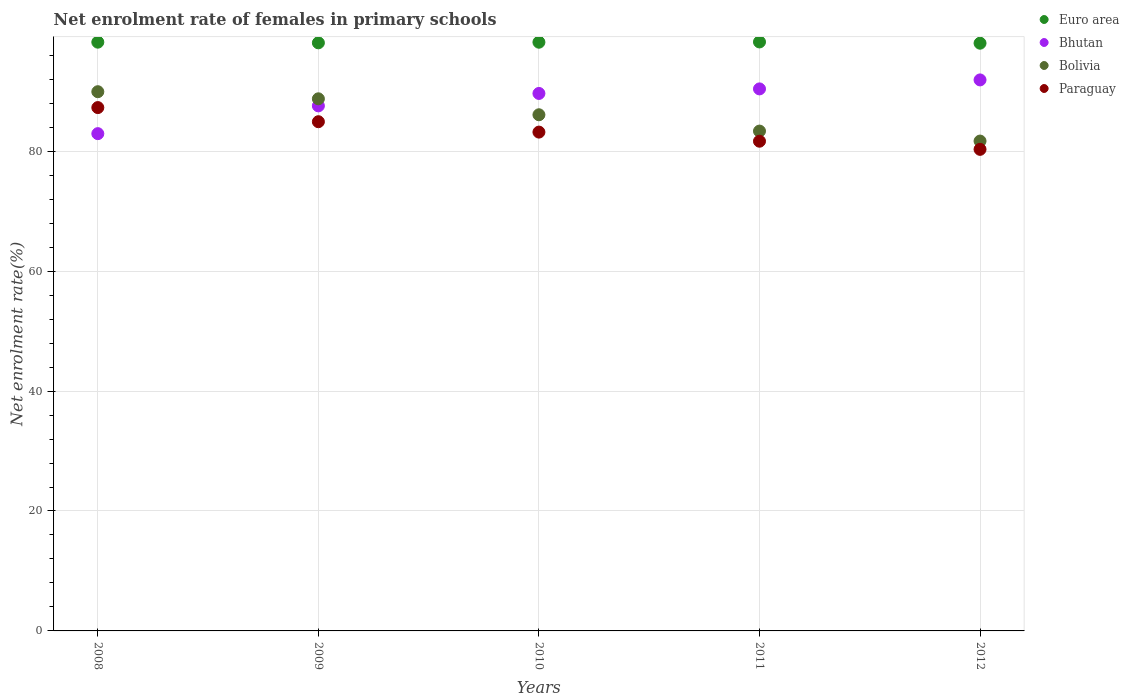What is the net enrolment rate of females in primary schools in Bolivia in 2010?
Provide a short and direct response. 86.08. Across all years, what is the maximum net enrolment rate of females in primary schools in Paraguay?
Ensure brevity in your answer.  87.28. Across all years, what is the minimum net enrolment rate of females in primary schools in Euro area?
Provide a succinct answer. 98.01. In which year was the net enrolment rate of females in primary schools in Paraguay maximum?
Your response must be concise. 2008. In which year was the net enrolment rate of females in primary schools in Bhutan minimum?
Your answer should be compact. 2008. What is the total net enrolment rate of females in primary schools in Euro area in the graph?
Your answer should be very brief. 490.67. What is the difference between the net enrolment rate of females in primary schools in Bolivia in 2010 and that in 2011?
Offer a very short reply. 2.72. What is the difference between the net enrolment rate of females in primary schools in Bolivia in 2010 and the net enrolment rate of females in primary schools in Euro area in 2008?
Your response must be concise. -12.11. What is the average net enrolment rate of females in primary schools in Euro area per year?
Your answer should be very brief. 98.13. In the year 2012, what is the difference between the net enrolment rate of females in primary schools in Euro area and net enrolment rate of females in primary schools in Bhutan?
Provide a succinct answer. 6.12. What is the ratio of the net enrolment rate of females in primary schools in Bhutan in 2009 to that in 2011?
Offer a very short reply. 0.97. Is the net enrolment rate of females in primary schools in Bolivia in 2008 less than that in 2012?
Your response must be concise. No. Is the difference between the net enrolment rate of females in primary schools in Euro area in 2009 and 2011 greater than the difference between the net enrolment rate of females in primary schools in Bhutan in 2009 and 2011?
Provide a short and direct response. Yes. What is the difference between the highest and the second highest net enrolment rate of females in primary schools in Paraguay?
Make the answer very short. 2.36. What is the difference between the highest and the lowest net enrolment rate of females in primary schools in Bhutan?
Provide a short and direct response. 8.96. Does the net enrolment rate of females in primary schools in Bolivia monotonically increase over the years?
Give a very brief answer. No. How many dotlines are there?
Your answer should be compact. 4. Does the graph contain grids?
Make the answer very short. Yes. How many legend labels are there?
Keep it short and to the point. 4. How are the legend labels stacked?
Your answer should be very brief. Vertical. What is the title of the graph?
Your answer should be compact. Net enrolment rate of females in primary schools. What is the label or title of the X-axis?
Provide a short and direct response. Years. What is the label or title of the Y-axis?
Keep it short and to the point. Net enrolment rate(%). What is the Net enrolment rate(%) of Euro area in 2008?
Your answer should be compact. 98.19. What is the Net enrolment rate(%) in Bhutan in 2008?
Give a very brief answer. 82.93. What is the Net enrolment rate(%) of Bolivia in 2008?
Provide a succinct answer. 89.92. What is the Net enrolment rate(%) in Paraguay in 2008?
Your answer should be compact. 87.28. What is the Net enrolment rate(%) in Euro area in 2009?
Your answer should be compact. 98.08. What is the Net enrolment rate(%) of Bhutan in 2009?
Provide a short and direct response. 87.56. What is the Net enrolment rate(%) of Bolivia in 2009?
Provide a short and direct response. 88.74. What is the Net enrolment rate(%) of Paraguay in 2009?
Your answer should be very brief. 84.92. What is the Net enrolment rate(%) of Euro area in 2010?
Provide a short and direct response. 98.18. What is the Net enrolment rate(%) of Bhutan in 2010?
Ensure brevity in your answer.  89.63. What is the Net enrolment rate(%) in Bolivia in 2010?
Make the answer very short. 86.08. What is the Net enrolment rate(%) in Paraguay in 2010?
Your answer should be compact. 83.19. What is the Net enrolment rate(%) in Euro area in 2011?
Ensure brevity in your answer.  98.22. What is the Net enrolment rate(%) in Bhutan in 2011?
Give a very brief answer. 90.39. What is the Net enrolment rate(%) of Bolivia in 2011?
Make the answer very short. 83.36. What is the Net enrolment rate(%) of Paraguay in 2011?
Provide a succinct answer. 81.67. What is the Net enrolment rate(%) in Euro area in 2012?
Offer a terse response. 98.01. What is the Net enrolment rate(%) in Bhutan in 2012?
Your answer should be compact. 91.89. What is the Net enrolment rate(%) in Bolivia in 2012?
Your answer should be compact. 81.69. What is the Net enrolment rate(%) in Paraguay in 2012?
Offer a very short reply. 80.31. Across all years, what is the maximum Net enrolment rate(%) of Euro area?
Make the answer very short. 98.22. Across all years, what is the maximum Net enrolment rate(%) of Bhutan?
Give a very brief answer. 91.89. Across all years, what is the maximum Net enrolment rate(%) of Bolivia?
Keep it short and to the point. 89.92. Across all years, what is the maximum Net enrolment rate(%) of Paraguay?
Provide a succinct answer. 87.28. Across all years, what is the minimum Net enrolment rate(%) of Euro area?
Your response must be concise. 98.01. Across all years, what is the minimum Net enrolment rate(%) of Bhutan?
Your answer should be compact. 82.93. Across all years, what is the minimum Net enrolment rate(%) of Bolivia?
Keep it short and to the point. 81.69. Across all years, what is the minimum Net enrolment rate(%) in Paraguay?
Your answer should be compact. 80.31. What is the total Net enrolment rate(%) in Euro area in the graph?
Provide a succinct answer. 490.67. What is the total Net enrolment rate(%) of Bhutan in the graph?
Provide a short and direct response. 442.41. What is the total Net enrolment rate(%) in Bolivia in the graph?
Offer a terse response. 429.79. What is the total Net enrolment rate(%) in Paraguay in the graph?
Provide a succinct answer. 417.36. What is the difference between the Net enrolment rate(%) in Euro area in 2008 and that in 2009?
Your answer should be compact. 0.11. What is the difference between the Net enrolment rate(%) of Bhutan in 2008 and that in 2009?
Make the answer very short. -4.63. What is the difference between the Net enrolment rate(%) of Bolivia in 2008 and that in 2009?
Give a very brief answer. 1.18. What is the difference between the Net enrolment rate(%) of Paraguay in 2008 and that in 2009?
Your answer should be very brief. 2.36. What is the difference between the Net enrolment rate(%) in Euro area in 2008 and that in 2010?
Provide a short and direct response. 0.01. What is the difference between the Net enrolment rate(%) in Bhutan in 2008 and that in 2010?
Your answer should be very brief. -6.71. What is the difference between the Net enrolment rate(%) of Bolivia in 2008 and that in 2010?
Make the answer very short. 3.85. What is the difference between the Net enrolment rate(%) of Paraguay in 2008 and that in 2010?
Offer a very short reply. 4.09. What is the difference between the Net enrolment rate(%) in Euro area in 2008 and that in 2011?
Provide a short and direct response. -0.04. What is the difference between the Net enrolment rate(%) in Bhutan in 2008 and that in 2011?
Your response must be concise. -7.46. What is the difference between the Net enrolment rate(%) of Bolivia in 2008 and that in 2011?
Provide a succinct answer. 6.57. What is the difference between the Net enrolment rate(%) of Paraguay in 2008 and that in 2011?
Keep it short and to the point. 5.61. What is the difference between the Net enrolment rate(%) of Euro area in 2008 and that in 2012?
Provide a succinct answer. 0.17. What is the difference between the Net enrolment rate(%) of Bhutan in 2008 and that in 2012?
Your answer should be compact. -8.96. What is the difference between the Net enrolment rate(%) in Bolivia in 2008 and that in 2012?
Keep it short and to the point. 8.23. What is the difference between the Net enrolment rate(%) in Paraguay in 2008 and that in 2012?
Offer a terse response. 6.97. What is the difference between the Net enrolment rate(%) of Euro area in 2009 and that in 2010?
Provide a short and direct response. -0.1. What is the difference between the Net enrolment rate(%) in Bhutan in 2009 and that in 2010?
Your answer should be very brief. -2.07. What is the difference between the Net enrolment rate(%) in Bolivia in 2009 and that in 2010?
Give a very brief answer. 2.66. What is the difference between the Net enrolment rate(%) in Paraguay in 2009 and that in 2010?
Offer a terse response. 1.73. What is the difference between the Net enrolment rate(%) in Euro area in 2009 and that in 2011?
Your answer should be very brief. -0.15. What is the difference between the Net enrolment rate(%) in Bhutan in 2009 and that in 2011?
Offer a terse response. -2.83. What is the difference between the Net enrolment rate(%) in Bolivia in 2009 and that in 2011?
Provide a succinct answer. 5.38. What is the difference between the Net enrolment rate(%) of Paraguay in 2009 and that in 2011?
Give a very brief answer. 3.25. What is the difference between the Net enrolment rate(%) of Euro area in 2009 and that in 2012?
Provide a short and direct response. 0.06. What is the difference between the Net enrolment rate(%) in Bhutan in 2009 and that in 2012?
Your response must be concise. -4.33. What is the difference between the Net enrolment rate(%) in Bolivia in 2009 and that in 2012?
Provide a short and direct response. 7.05. What is the difference between the Net enrolment rate(%) of Paraguay in 2009 and that in 2012?
Offer a very short reply. 4.61. What is the difference between the Net enrolment rate(%) in Euro area in 2010 and that in 2011?
Provide a short and direct response. -0.04. What is the difference between the Net enrolment rate(%) in Bhutan in 2010 and that in 2011?
Provide a short and direct response. -0.76. What is the difference between the Net enrolment rate(%) in Bolivia in 2010 and that in 2011?
Give a very brief answer. 2.72. What is the difference between the Net enrolment rate(%) of Paraguay in 2010 and that in 2011?
Offer a very short reply. 1.52. What is the difference between the Net enrolment rate(%) of Euro area in 2010 and that in 2012?
Make the answer very short. 0.16. What is the difference between the Net enrolment rate(%) in Bhutan in 2010 and that in 2012?
Provide a short and direct response. -2.26. What is the difference between the Net enrolment rate(%) of Bolivia in 2010 and that in 2012?
Keep it short and to the point. 4.39. What is the difference between the Net enrolment rate(%) in Paraguay in 2010 and that in 2012?
Ensure brevity in your answer.  2.88. What is the difference between the Net enrolment rate(%) of Euro area in 2011 and that in 2012?
Give a very brief answer. 0.21. What is the difference between the Net enrolment rate(%) in Bhutan in 2011 and that in 2012?
Make the answer very short. -1.5. What is the difference between the Net enrolment rate(%) in Bolivia in 2011 and that in 2012?
Offer a terse response. 1.66. What is the difference between the Net enrolment rate(%) of Paraguay in 2011 and that in 2012?
Give a very brief answer. 1.36. What is the difference between the Net enrolment rate(%) in Euro area in 2008 and the Net enrolment rate(%) in Bhutan in 2009?
Your answer should be very brief. 10.62. What is the difference between the Net enrolment rate(%) of Euro area in 2008 and the Net enrolment rate(%) of Bolivia in 2009?
Keep it short and to the point. 9.45. What is the difference between the Net enrolment rate(%) in Euro area in 2008 and the Net enrolment rate(%) in Paraguay in 2009?
Offer a terse response. 13.27. What is the difference between the Net enrolment rate(%) in Bhutan in 2008 and the Net enrolment rate(%) in Bolivia in 2009?
Keep it short and to the point. -5.81. What is the difference between the Net enrolment rate(%) of Bhutan in 2008 and the Net enrolment rate(%) of Paraguay in 2009?
Make the answer very short. -1.99. What is the difference between the Net enrolment rate(%) in Bolivia in 2008 and the Net enrolment rate(%) in Paraguay in 2009?
Give a very brief answer. 5. What is the difference between the Net enrolment rate(%) of Euro area in 2008 and the Net enrolment rate(%) of Bhutan in 2010?
Provide a short and direct response. 8.55. What is the difference between the Net enrolment rate(%) of Euro area in 2008 and the Net enrolment rate(%) of Bolivia in 2010?
Your answer should be compact. 12.11. What is the difference between the Net enrolment rate(%) of Euro area in 2008 and the Net enrolment rate(%) of Paraguay in 2010?
Provide a succinct answer. 15. What is the difference between the Net enrolment rate(%) in Bhutan in 2008 and the Net enrolment rate(%) in Bolivia in 2010?
Provide a short and direct response. -3.15. What is the difference between the Net enrolment rate(%) of Bhutan in 2008 and the Net enrolment rate(%) of Paraguay in 2010?
Make the answer very short. -0.26. What is the difference between the Net enrolment rate(%) of Bolivia in 2008 and the Net enrolment rate(%) of Paraguay in 2010?
Make the answer very short. 6.74. What is the difference between the Net enrolment rate(%) of Euro area in 2008 and the Net enrolment rate(%) of Bhutan in 2011?
Ensure brevity in your answer.  7.79. What is the difference between the Net enrolment rate(%) in Euro area in 2008 and the Net enrolment rate(%) in Bolivia in 2011?
Provide a succinct answer. 14.83. What is the difference between the Net enrolment rate(%) of Euro area in 2008 and the Net enrolment rate(%) of Paraguay in 2011?
Your answer should be very brief. 16.52. What is the difference between the Net enrolment rate(%) in Bhutan in 2008 and the Net enrolment rate(%) in Bolivia in 2011?
Provide a short and direct response. -0.43. What is the difference between the Net enrolment rate(%) of Bhutan in 2008 and the Net enrolment rate(%) of Paraguay in 2011?
Your answer should be very brief. 1.26. What is the difference between the Net enrolment rate(%) in Bolivia in 2008 and the Net enrolment rate(%) in Paraguay in 2011?
Offer a terse response. 8.26. What is the difference between the Net enrolment rate(%) of Euro area in 2008 and the Net enrolment rate(%) of Bhutan in 2012?
Provide a succinct answer. 6.3. What is the difference between the Net enrolment rate(%) in Euro area in 2008 and the Net enrolment rate(%) in Bolivia in 2012?
Make the answer very short. 16.49. What is the difference between the Net enrolment rate(%) of Euro area in 2008 and the Net enrolment rate(%) of Paraguay in 2012?
Your response must be concise. 17.87. What is the difference between the Net enrolment rate(%) in Bhutan in 2008 and the Net enrolment rate(%) in Bolivia in 2012?
Make the answer very short. 1.24. What is the difference between the Net enrolment rate(%) of Bhutan in 2008 and the Net enrolment rate(%) of Paraguay in 2012?
Your response must be concise. 2.62. What is the difference between the Net enrolment rate(%) in Bolivia in 2008 and the Net enrolment rate(%) in Paraguay in 2012?
Your response must be concise. 9.61. What is the difference between the Net enrolment rate(%) of Euro area in 2009 and the Net enrolment rate(%) of Bhutan in 2010?
Your answer should be compact. 8.44. What is the difference between the Net enrolment rate(%) in Euro area in 2009 and the Net enrolment rate(%) in Bolivia in 2010?
Your answer should be compact. 12. What is the difference between the Net enrolment rate(%) of Euro area in 2009 and the Net enrolment rate(%) of Paraguay in 2010?
Ensure brevity in your answer.  14.89. What is the difference between the Net enrolment rate(%) in Bhutan in 2009 and the Net enrolment rate(%) in Bolivia in 2010?
Your answer should be compact. 1.48. What is the difference between the Net enrolment rate(%) in Bhutan in 2009 and the Net enrolment rate(%) in Paraguay in 2010?
Your response must be concise. 4.38. What is the difference between the Net enrolment rate(%) of Bolivia in 2009 and the Net enrolment rate(%) of Paraguay in 2010?
Your response must be concise. 5.55. What is the difference between the Net enrolment rate(%) of Euro area in 2009 and the Net enrolment rate(%) of Bhutan in 2011?
Give a very brief answer. 7.69. What is the difference between the Net enrolment rate(%) of Euro area in 2009 and the Net enrolment rate(%) of Bolivia in 2011?
Offer a terse response. 14.72. What is the difference between the Net enrolment rate(%) of Euro area in 2009 and the Net enrolment rate(%) of Paraguay in 2011?
Offer a very short reply. 16.41. What is the difference between the Net enrolment rate(%) in Bhutan in 2009 and the Net enrolment rate(%) in Bolivia in 2011?
Give a very brief answer. 4.21. What is the difference between the Net enrolment rate(%) in Bhutan in 2009 and the Net enrolment rate(%) in Paraguay in 2011?
Ensure brevity in your answer.  5.89. What is the difference between the Net enrolment rate(%) of Bolivia in 2009 and the Net enrolment rate(%) of Paraguay in 2011?
Offer a very short reply. 7.07. What is the difference between the Net enrolment rate(%) in Euro area in 2009 and the Net enrolment rate(%) in Bhutan in 2012?
Your response must be concise. 6.19. What is the difference between the Net enrolment rate(%) of Euro area in 2009 and the Net enrolment rate(%) of Bolivia in 2012?
Offer a terse response. 16.38. What is the difference between the Net enrolment rate(%) in Euro area in 2009 and the Net enrolment rate(%) in Paraguay in 2012?
Your answer should be compact. 17.77. What is the difference between the Net enrolment rate(%) of Bhutan in 2009 and the Net enrolment rate(%) of Bolivia in 2012?
Your answer should be very brief. 5.87. What is the difference between the Net enrolment rate(%) in Bhutan in 2009 and the Net enrolment rate(%) in Paraguay in 2012?
Your answer should be very brief. 7.25. What is the difference between the Net enrolment rate(%) in Bolivia in 2009 and the Net enrolment rate(%) in Paraguay in 2012?
Offer a terse response. 8.43. What is the difference between the Net enrolment rate(%) of Euro area in 2010 and the Net enrolment rate(%) of Bhutan in 2011?
Your response must be concise. 7.79. What is the difference between the Net enrolment rate(%) of Euro area in 2010 and the Net enrolment rate(%) of Bolivia in 2011?
Your response must be concise. 14.82. What is the difference between the Net enrolment rate(%) in Euro area in 2010 and the Net enrolment rate(%) in Paraguay in 2011?
Make the answer very short. 16.51. What is the difference between the Net enrolment rate(%) of Bhutan in 2010 and the Net enrolment rate(%) of Bolivia in 2011?
Offer a very short reply. 6.28. What is the difference between the Net enrolment rate(%) of Bhutan in 2010 and the Net enrolment rate(%) of Paraguay in 2011?
Keep it short and to the point. 7.97. What is the difference between the Net enrolment rate(%) of Bolivia in 2010 and the Net enrolment rate(%) of Paraguay in 2011?
Give a very brief answer. 4.41. What is the difference between the Net enrolment rate(%) of Euro area in 2010 and the Net enrolment rate(%) of Bhutan in 2012?
Keep it short and to the point. 6.29. What is the difference between the Net enrolment rate(%) of Euro area in 2010 and the Net enrolment rate(%) of Bolivia in 2012?
Ensure brevity in your answer.  16.49. What is the difference between the Net enrolment rate(%) of Euro area in 2010 and the Net enrolment rate(%) of Paraguay in 2012?
Ensure brevity in your answer.  17.87. What is the difference between the Net enrolment rate(%) of Bhutan in 2010 and the Net enrolment rate(%) of Bolivia in 2012?
Make the answer very short. 7.94. What is the difference between the Net enrolment rate(%) of Bhutan in 2010 and the Net enrolment rate(%) of Paraguay in 2012?
Ensure brevity in your answer.  9.32. What is the difference between the Net enrolment rate(%) in Bolivia in 2010 and the Net enrolment rate(%) in Paraguay in 2012?
Make the answer very short. 5.77. What is the difference between the Net enrolment rate(%) of Euro area in 2011 and the Net enrolment rate(%) of Bhutan in 2012?
Give a very brief answer. 6.33. What is the difference between the Net enrolment rate(%) in Euro area in 2011 and the Net enrolment rate(%) in Bolivia in 2012?
Offer a very short reply. 16.53. What is the difference between the Net enrolment rate(%) in Euro area in 2011 and the Net enrolment rate(%) in Paraguay in 2012?
Give a very brief answer. 17.91. What is the difference between the Net enrolment rate(%) in Bhutan in 2011 and the Net enrolment rate(%) in Bolivia in 2012?
Your response must be concise. 8.7. What is the difference between the Net enrolment rate(%) of Bhutan in 2011 and the Net enrolment rate(%) of Paraguay in 2012?
Your response must be concise. 10.08. What is the difference between the Net enrolment rate(%) in Bolivia in 2011 and the Net enrolment rate(%) in Paraguay in 2012?
Ensure brevity in your answer.  3.05. What is the average Net enrolment rate(%) in Euro area per year?
Make the answer very short. 98.13. What is the average Net enrolment rate(%) of Bhutan per year?
Give a very brief answer. 88.48. What is the average Net enrolment rate(%) in Bolivia per year?
Your answer should be compact. 85.96. What is the average Net enrolment rate(%) of Paraguay per year?
Offer a terse response. 83.47. In the year 2008, what is the difference between the Net enrolment rate(%) in Euro area and Net enrolment rate(%) in Bhutan?
Your response must be concise. 15.26. In the year 2008, what is the difference between the Net enrolment rate(%) of Euro area and Net enrolment rate(%) of Bolivia?
Provide a succinct answer. 8.26. In the year 2008, what is the difference between the Net enrolment rate(%) of Euro area and Net enrolment rate(%) of Paraguay?
Your answer should be very brief. 10.91. In the year 2008, what is the difference between the Net enrolment rate(%) in Bhutan and Net enrolment rate(%) in Bolivia?
Keep it short and to the point. -7. In the year 2008, what is the difference between the Net enrolment rate(%) of Bhutan and Net enrolment rate(%) of Paraguay?
Ensure brevity in your answer.  -4.35. In the year 2008, what is the difference between the Net enrolment rate(%) in Bolivia and Net enrolment rate(%) in Paraguay?
Offer a very short reply. 2.65. In the year 2009, what is the difference between the Net enrolment rate(%) in Euro area and Net enrolment rate(%) in Bhutan?
Give a very brief answer. 10.51. In the year 2009, what is the difference between the Net enrolment rate(%) of Euro area and Net enrolment rate(%) of Bolivia?
Offer a terse response. 9.34. In the year 2009, what is the difference between the Net enrolment rate(%) of Euro area and Net enrolment rate(%) of Paraguay?
Offer a terse response. 13.16. In the year 2009, what is the difference between the Net enrolment rate(%) of Bhutan and Net enrolment rate(%) of Bolivia?
Your answer should be very brief. -1.18. In the year 2009, what is the difference between the Net enrolment rate(%) of Bhutan and Net enrolment rate(%) of Paraguay?
Offer a very short reply. 2.64. In the year 2009, what is the difference between the Net enrolment rate(%) of Bolivia and Net enrolment rate(%) of Paraguay?
Ensure brevity in your answer.  3.82. In the year 2010, what is the difference between the Net enrolment rate(%) in Euro area and Net enrolment rate(%) in Bhutan?
Provide a succinct answer. 8.54. In the year 2010, what is the difference between the Net enrolment rate(%) of Euro area and Net enrolment rate(%) of Bolivia?
Make the answer very short. 12.1. In the year 2010, what is the difference between the Net enrolment rate(%) of Euro area and Net enrolment rate(%) of Paraguay?
Your response must be concise. 14.99. In the year 2010, what is the difference between the Net enrolment rate(%) in Bhutan and Net enrolment rate(%) in Bolivia?
Make the answer very short. 3.56. In the year 2010, what is the difference between the Net enrolment rate(%) in Bhutan and Net enrolment rate(%) in Paraguay?
Provide a short and direct response. 6.45. In the year 2010, what is the difference between the Net enrolment rate(%) in Bolivia and Net enrolment rate(%) in Paraguay?
Provide a short and direct response. 2.89. In the year 2011, what is the difference between the Net enrolment rate(%) of Euro area and Net enrolment rate(%) of Bhutan?
Ensure brevity in your answer.  7.83. In the year 2011, what is the difference between the Net enrolment rate(%) of Euro area and Net enrolment rate(%) of Bolivia?
Offer a very short reply. 14.87. In the year 2011, what is the difference between the Net enrolment rate(%) in Euro area and Net enrolment rate(%) in Paraguay?
Ensure brevity in your answer.  16.55. In the year 2011, what is the difference between the Net enrolment rate(%) of Bhutan and Net enrolment rate(%) of Bolivia?
Keep it short and to the point. 7.04. In the year 2011, what is the difference between the Net enrolment rate(%) in Bhutan and Net enrolment rate(%) in Paraguay?
Ensure brevity in your answer.  8.72. In the year 2011, what is the difference between the Net enrolment rate(%) in Bolivia and Net enrolment rate(%) in Paraguay?
Your answer should be very brief. 1.69. In the year 2012, what is the difference between the Net enrolment rate(%) of Euro area and Net enrolment rate(%) of Bhutan?
Ensure brevity in your answer.  6.12. In the year 2012, what is the difference between the Net enrolment rate(%) in Euro area and Net enrolment rate(%) in Bolivia?
Your answer should be very brief. 16.32. In the year 2012, what is the difference between the Net enrolment rate(%) in Euro area and Net enrolment rate(%) in Paraguay?
Provide a succinct answer. 17.7. In the year 2012, what is the difference between the Net enrolment rate(%) of Bhutan and Net enrolment rate(%) of Bolivia?
Ensure brevity in your answer.  10.2. In the year 2012, what is the difference between the Net enrolment rate(%) in Bhutan and Net enrolment rate(%) in Paraguay?
Keep it short and to the point. 11.58. In the year 2012, what is the difference between the Net enrolment rate(%) in Bolivia and Net enrolment rate(%) in Paraguay?
Keep it short and to the point. 1.38. What is the ratio of the Net enrolment rate(%) of Bhutan in 2008 to that in 2009?
Give a very brief answer. 0.95. What is the ratio of the Net enrolment rate(%) of Bolivia in 2008 to that in 2009?
Make the answer very short. 1.01. What is the ratio of the Net enrolment rate(%) in Paraguay in 2008 to that in 2009?
Give a very brief answer. 1.03. What is the ratio of the Net enrolment rate(%) in Euro area in 2008 to that in 2010?
Give a very brief answer. 1. What is the ratio of the Net enrolment rate(%) of Bhutan in 2008 to that in 2010?
Your answer should be compact. 0.93. What is the ratio of the Net enrolment rate(%) of Bolivia in 2008 to that in 2010?
Keep it short and to the point. 1.04. What is the ratio of the Net enrolment rate(%) in Paraguay in 2008 to that in 2010?
Keep it short and to the point. 1.05. What is the ratio of the Net enrolment rate(%) in Bhutan in 2008 to that in 2011?
Offer a very short reply. 0.92. What is the ratio of the Net enrolment rate(%) of Bolivia in 2008 to that in 2011?
Provide a short and direct response. 1.08. What is the ratio of the Net enrolment rate(%) in Paraguay in 2008 to that in 2011?
Give a very brief answer. 1.07. What is the ratio of the Net enrolment rate(%) in Euro area in 2008 to that in 2012?
Offer a terse response. 1. What is the ratio of the Net enrolment rate(%) of Bhutan in 2008 to that in 2012?
Your answer should be very brief. 0.9. What is the ratio of the Net enrolment rate(%) of Bolivia in 2008 to that in 2012?
Offer a terse response. 1.1. What is the ratio of the Net enrolment rate(%) of Paraguay in 2008 to that in 2012?
Keep it short and to the point. 1.09. What is the ratio of the Net enrolment rate(%) of Euro area in 2009 to that in 2010?
Offer a very short reply. 1. What is the ratio of the Net enrolment rate(%) in Bhutan in 2009 to that in 2010?
Offer a terse response. 0.98. What is the ratio of the Net enrolment rate(%) in Bolivia in 2009 to that in 2010?
Offer a very short reply. 1.03. What is the ratio of the Net enrolment rate(%) in Paraguay in 2009 to that in 2010?
Make the answer very short. 1.02. What is the ratio of the Net enrolment rate(%) in Euro area in 2009 to that in 2011?
Make the answer very short. 1. What is the ratio of the Net enrolment rate(%) of Bhutan in 2009 to that in 2011?
Offer a terse response. 0.97. What is the ratio of the Net enrolment rate(%) of Bolivia in 2009 to that in 2011?
Offer a very short reply. 1.06. What is the ratio of the Net enrolment rate(%) in Paraguay in 2009 to that in 2011?
Your response must be concise. 1.04. What is the ratio of the Net enrolment rate(%) of Bhutan in 2009 to that in 2012?
Offer a very short reply. 0.95. What is the ratio of the Net enrolment rate(%) of Bolivia in 2009 to that in 2012?
Provide a succinct answer. 1.09. What is the ratio of the Net enrolment rate(%) in Paraguay in 2009 to that in 2012?
Provide a short and direct response. 1.06. What is the ratio of the Net enrolment rate(%) in Bhutan in 2010 to that in 2011?
Your answer should be very brief. 0.99. What is the ratio of the Net enrolment rate(%) of Bolivia in 2010 to that in 2011?
Offer a terse response. 1.03. What is the ratio of the Net enrolment rate(%) in Paraguay in 2010 to that in 2011?
Ensure brevity in your answer.  1.02. What is the ratio of the Net enrolment rate(%) in Euro area in 2010 to that in 2012?
Make the answer very short. 1. What is the ratio of the Net enrolment rate(%) in Bhutan in 2010 to that in 2012?
Give a very brief answer. 0.98. What is the ratio of the Net enrolment rate(%) of Bolivia in 2010 to that in 2012?
Make the answer very short. 1.05. What is the ratio of the Net enrolment rate(%) of Paraguay in 2010 to that in 2012?
Make the answer very short. 1.04. What is the ratio of the Net enrolment rate(%) in Bhutan in 2011 to that in 2012?
Offer a very short reply. 0.98. What is the ratio of the Net enrolment rate(%) of Bolivia in 2011 to that in 2012?
Your answer should be very brief. 1.02. What is the ratio of the Net enrolment rate(%) in Paraguay in 2011 to that in 2012?
Offer a terse response. 1.02. What is the difference between the highest and the second highest Net enrolment rate(%) in Euro area?
Your answer should be very brief. 0.04. What is the difference between the highest and the second highest Net enrolment rate(%) of Bhutan?
Make the answer very short. 1.5. What is the difference between the highest and the second highest Net enrolment rate(%) of Bolivia?
Offer a very short reply. 1.18. What is the difference between the highest and the second highest Net enrolment rate(%) of Paraguay?
Give a very brief answer. 2.36. What is the difference between the highest and the lowest Net enrolment rate(%) in Euro area?
Offer a terse response. 0.21. What is the difference between the highest and the lowest Net enrolment rate(%) in Bhutan?
Make the answer very short. 8.96. What is the difference between the highest and the lowest Net enrolment rate(%) of Bolivia?
Keep it short and to the point. 8.23. What is the difference between the highest and the lowest Net enrolment rate(%) of Paraguay?
Give a very brief answer. 6.97. 